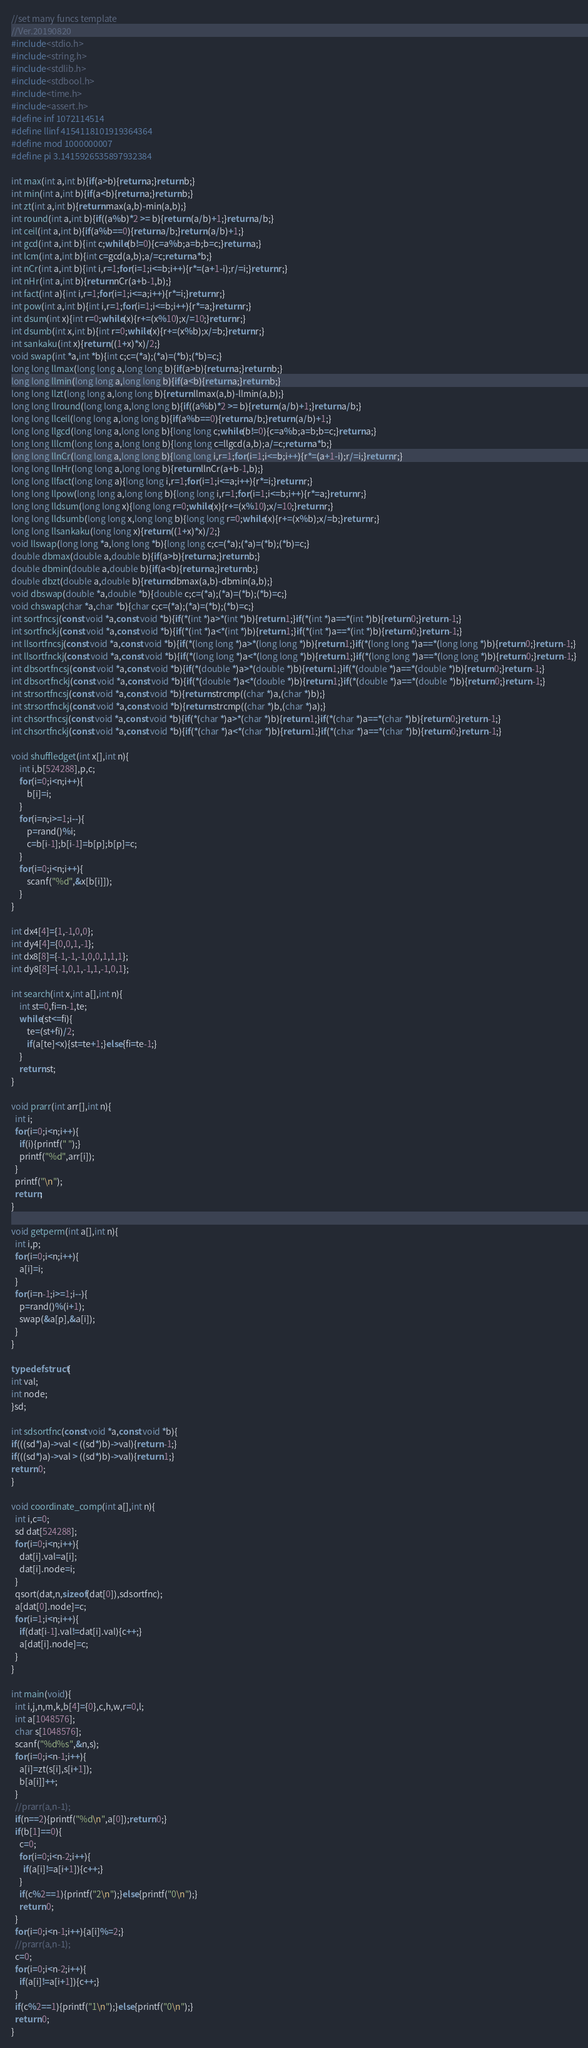Convert code to text. <code><loc_0><loc_0><loc_500><loc_500><_C_>//set many funcs template
//Ver.20190820
#include<stdio.h>
#include<string.h>
#include<stdlib.h>
#include<stdbool.h>
#include<time.h>
#include<assert.h>
#define inf 1072114514
#define llinf 4154118101919364364
#define mod 1000000007
#define pi 3.1415926535897932384

int max(int a,int b){if(a>b){return a;}return b;}
int min(int a,int b){if(a<b){return a;}return b;}
int zt(int a,int b){return max(a,b)-min(a,b);}
int round(int a,int b){if((a%b)*2 >= b){return (a/b)+1;}return a/b;}
int ceil(int a,int b){if(a%b==0){return a/b;}return (a/b)+1;}
int gcd(int a,int b){int c;while(b!=0){c=a%b;a=b;b=c;}return a;}
int lcm(int a,int b){int c=gcd(a,b);a/=c;return a*b;}
int nCr(int a,int b){int i,r=1;for(i=1;i<=b;i++){r*=(a+1-i);r/=i;}return r;}
int nHr(int a,int b){return nCr(a+b-1,b);}
int fact(int a){int i,r=1;for(i=1;i<=a;i++){r*=i;}return r;}
int pow(int a,int b){int i,r=1;for(i=1;i<=b;i++){r*=a;}return r;}
int dsum(int x){int r=0;while(x){r+=(x%10);x/=10;}return r;}
int dsumb(int x,int b){int r=0;while(x){r+=(x%b);x/=b;}return r;}
int sankaku(int x){return ((1+x)*x)/2;}
void swap(int *a,int *b){int c;c=(*a);(*a)=(*b);(*b)=c;}
long long llmax(long long a,long long b){if(a>b){return a;}return b;}
long long llmin(long long a,long long b){if(a<b){return a;}return b;}
long long llzt(long long a,long long b){return llmax(a,b)-llmin(a,b);}
long long llround(long long a,long long b){if((a%b)*2 >= b){return (a/b)+1;}return a/b;}
long long llceil(long long a,long long b){if(a%b==0){return a/b;}return (a/b)+1;}
long long llgcd(long long a,long long b){long long c;while(b!=0){c=a%b;a=b;b=c;}return a;}
long long lllcm(long long a,long long b){long long c=llgcd(a,b);a/=c;return a*b;}
long long llnCr(long long a,long long b){long long i,r=1;for(i=1;i<=b;i++){r*=(a+1-i);r/=i;}return r;}
long long llnHr(long long a,long long b){return llnCr(a+b-1,b);}
long long llfact(long long a){long long i,r=1;for(i=1;i<=a;i++){r*=i;}return r;}
long long llpow(long long a,long long b){long long i,r=1;for(i=1;i<=b;i++){r*=a;}return r;}
long long lldsum(long long x){long long r=0;while(x){r+=(x%10);x/=10;}return r;}
long long lldsumb(long long x,long long b){long long r=0;while(x){r+=(x%b);x/=b;}return r;}
long long llsankaku(long long x){return ((1+x)*x)/2;}
void llswap(long long *a,long long *b){long long c;c=(*a);(*a)=(*b);(*b)=c;}
double dbmax(double a,double b){if(a>b){return a;}return b;}
double dbmin(double a,double b){if(a<b){return a;}return b;}
double dbzt(double a,double b){return dbmax(a,b)-dbmin(a,b);}
void dbswap(double *a,double *b){double c;c=(*a);(*a)=(*b);(*b)=c;}
void chswap(char *a,char *b){char c;c=(*a);(*a)=(*b);(*b)=c;}
int sortfncsj(const void *a,const void *b){if(*(int *)a>*(int *)b){return 1;}if(*(int *)a==*(int *)b){return 0;}return -1;}
int sortfnckj(const void *a,const void *b){if(*(int *)a<*(int *)b){return 1;}if(*(int *)a==*(int *)b){return 0;}return -1;}
int llsortfncsj(const void *a,const void *b){if(*(long long *)a>*(long long *)b){return 1;}if(*(long long *)a==*(long long *)b){return 0;}return -1;}
int llsortfnckj(const void *a,const void *b){if(*(long long *)a<*(long long *)b){return 1;}if(*(long long *)a==*(long long *)b){return 0;}return -1;}
int dbsortfncsj(const void *a,const void *b){if(*(double *)a>*(double *)b){return 1;}if(*(double *)a==*(double *)b){return 0;}return -1;}
int dbsortfnckj(const void *a,const void *b){if(*(double *)a<*(double *)b){return 1;}if(*(double *)a==*(double *)b){return 0;}return -1;}
int strsortfncsj(const void *a,const void *b){return strcmp((char *)a,(char *)b);}
int strsortfnckj(const void *a,const void *b){return strcmp((char *)b,(char *)a);}
int chsortfncsj(const void *a,const void *b){if(*(char *)a>*(char *)b){return 1;}if(*(char *)a==*(char *)b){return 0;}return -1;}
int chsortfnckj(const void *a,const void *b){if(*(char *)a<*(char *)b){return 1;}if(*(char *)a==*(char *)b){return 0;}return -1;}

void shuffledget(int x[],int n){
    int i,b[524288],p,c;
    for(i=0;i<n;i++){
        b[i]=i;
    }
    for(i=n;i>=1;i--){
        p=rand()%i;
        c=b[i-1];b[i-1]=b[p];b[p]=c;
    }
    for(i=0;i<n;i++){
        scanf("%d",&x[b[i]]);
    }
}

int dx4[4]={1,-1,0,0};
int dy4[4]={0,0,1,-1};
int dx8[8]={-1,-1,-1,0,0,1,1,1};
int dy8[8]={-1,0,1,-1,1,-1,0,1};

int search(int x,int a[],int n){
    int st=0,fi=n-1,te;
    while(st<=fi){
        te=(st+fi)/2;
        if(a[te]<x){st=te+1;}else{fi=te-1;}
    }
    return st;
}

void prarr(int arr[],int n){
  int i;
  for(i=0;i<n;i++){
    if(i){printf(" ");}
    printf("%d",arr[i]);
  }
  printf("\n");
  return;
}

void getperm(int a[],int n){
  int i,p;
  for(i=0;i<n;i++){
    a[i]=i;
  }
  for(i=n-1;i>=1;i--){
    p=rand()%(i+1);
    swap(&a[p],&a[i]);
  }
}

typedef struct{
int val;
int node;
}sd;

int sdsortfnc(const void *a,const void *b){
if(((sd*)a)->val < ((sd*)b)->val){return -1;}
if(((sd*)a)->val > ((sd*)b)->val){return 1;}
return 0;
}

void coordinate_comp(int a[],int n){
  int i,c=0;
  sd dat[524288];
  for(i=0;i<n;i++){
    dat[i].val=a[i];
    dat[i].node=i;
  }
  qsort(dat,n,sizeof(dat[0]),sdsortfnc);
  a[dat[0].node]=c;
  for(i=1;i<n;i++){
    if(dat[i-1].val!=dat[i].val){c++;}
    a[dat[i].node]=c;
  }
}

int main(void){
  int i,j,n,m,k,b[4]={0},c,h,w,r=0,l;
  int a[1048576];
  char s[1048576];
  scanf("%d%s",&n,s);
  for(i=0;i<n-1;i++){
    a[i]=zt(s[i],s[i+1]);
    b[a[i]]++;
  }
  //prarr(a,n-1);
  if(n==2){printf("%d\n",a[0]);return 0;}
  if(b[1]==0){
    c=0;
    for(i=0;i<n-2;i++){
      if(a[i]!=a[i+1]){c++;}
    }
    if(c%2==1){printf("2\n");}else{printf("0\n");}
    return 0;
  }
  for(i=0;i<n-1;i++){a[i]%=2;}
  //prarr(a,n-1);
  c=0;
  for(i=0;i<n-2;i++){
    if(a[i]!=a[i+1]){c++;}
  }
  if(c%2==1){printf("1\n");}else{printf("0\n");}
  return 0;
}
</code> 